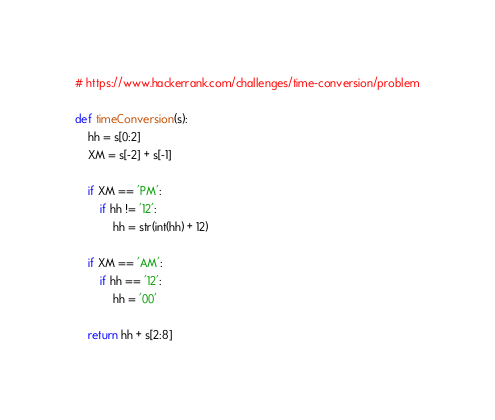<code> <loc_0><loc_0><loc_500><loc_500><_Python_># https://www.hackerrank.com/challenges/time-conversion/problem

def timeConversion(s):
    hh = s[0:2]
    XM = s[-2] + s[-1]

    if XM == 'PM':
        if hh != '12':
            hh = str(int(hh) + 12)
    
    if XM == 'AM':
        if hh == '12':
            hh = '00'

    return hh + s[2:8]
</code> 